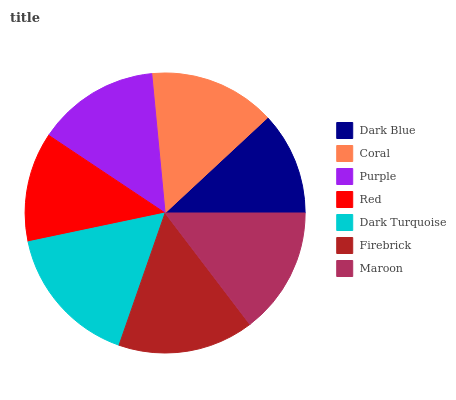Is Dark Blue the minimum?
Answer yes or no. Yes. Is Dark Turquoise the maximum?
Answer yes or no. Yes. Is Coral the minimum?
Answer yes or no. No. Is Coral the maximum?
Answer yes or no. No. Is Coral greater than Dark Blue?
Answer yes or no. Yes. Is Dark Blue less than Coral?
Answer yes or no. Yes. Is Dark Blue greater than Coral?
Answer yes or no. No. Is Coral less than Dark Blue?
Answer yes or no. No. Is Coral the high median?
Answer yes or no. Yes. Is Coral the low median?
Answer yes or no. Yes. Is Dark Turquoise the high median?
Answer yes or no. No. Is Dark Blue the low median?
Answer yes or no. No. 